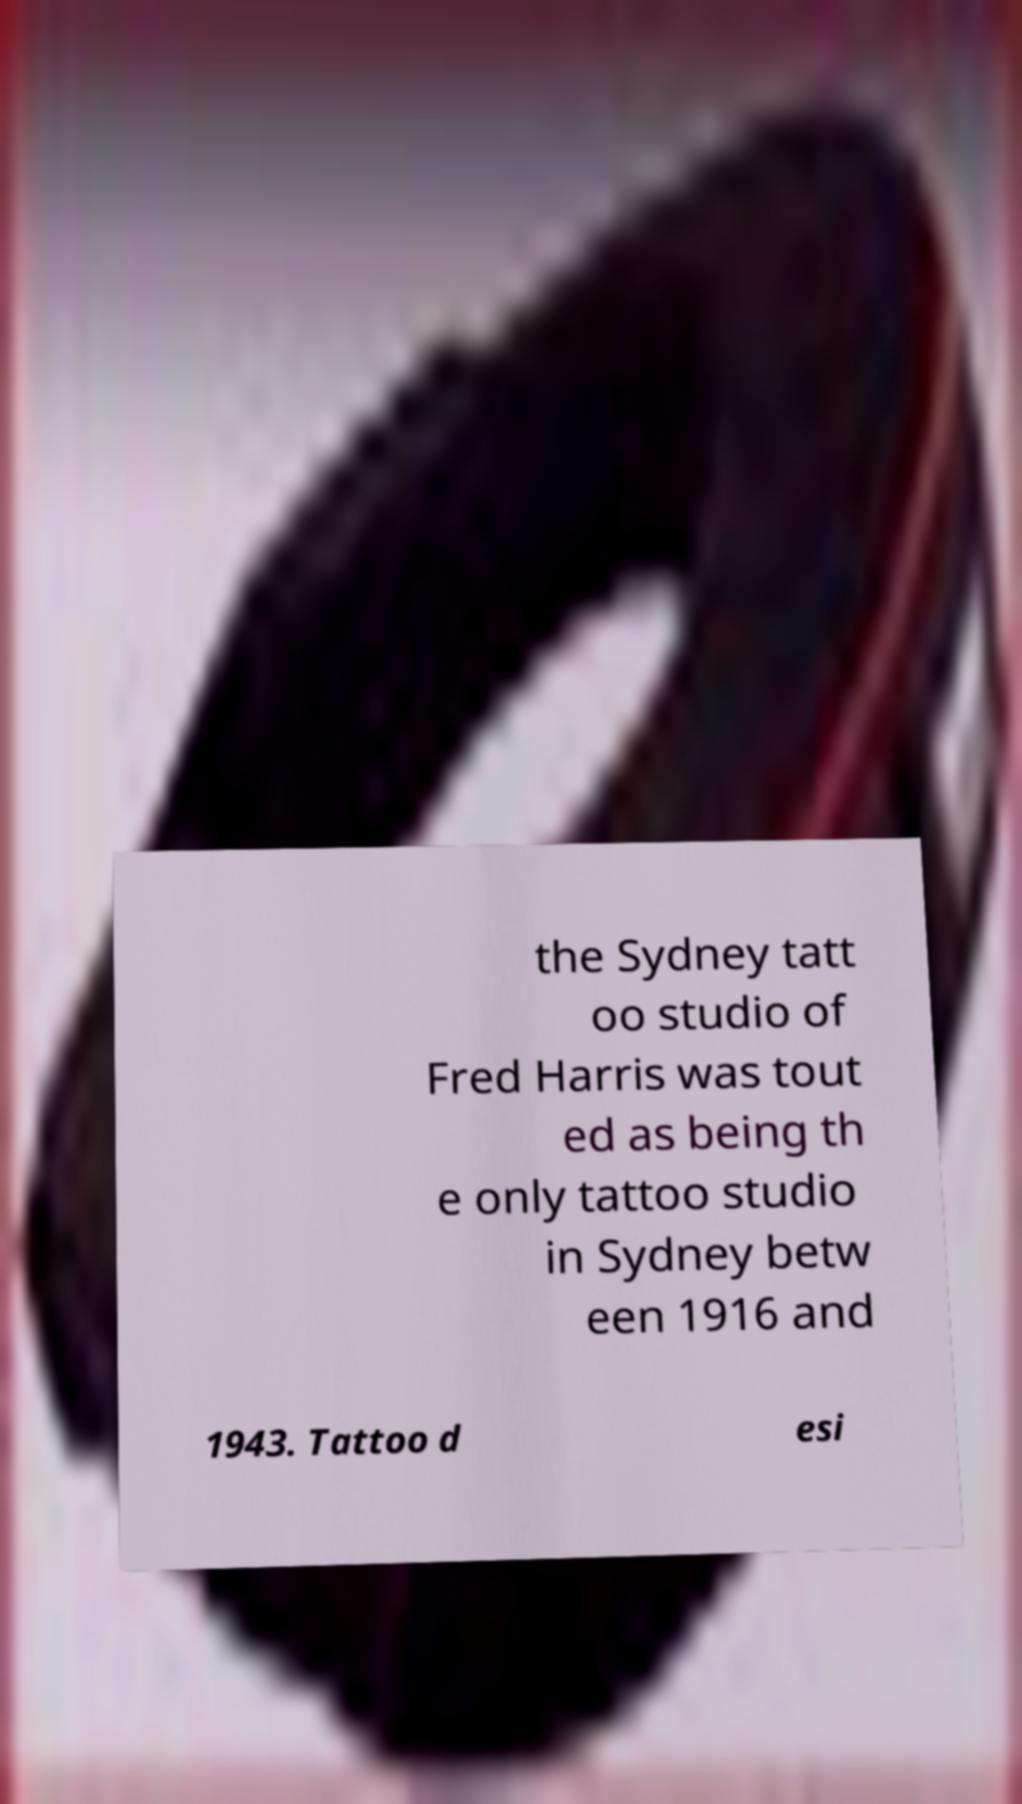What messages or text are displayed in this image? I need them in a readable, typed format. the Sydney tatt oo studio of Fred Harris was tout ed as being th e only tattoo studio in Sydney betw een 1916 and 1943. Tattoo d esi 